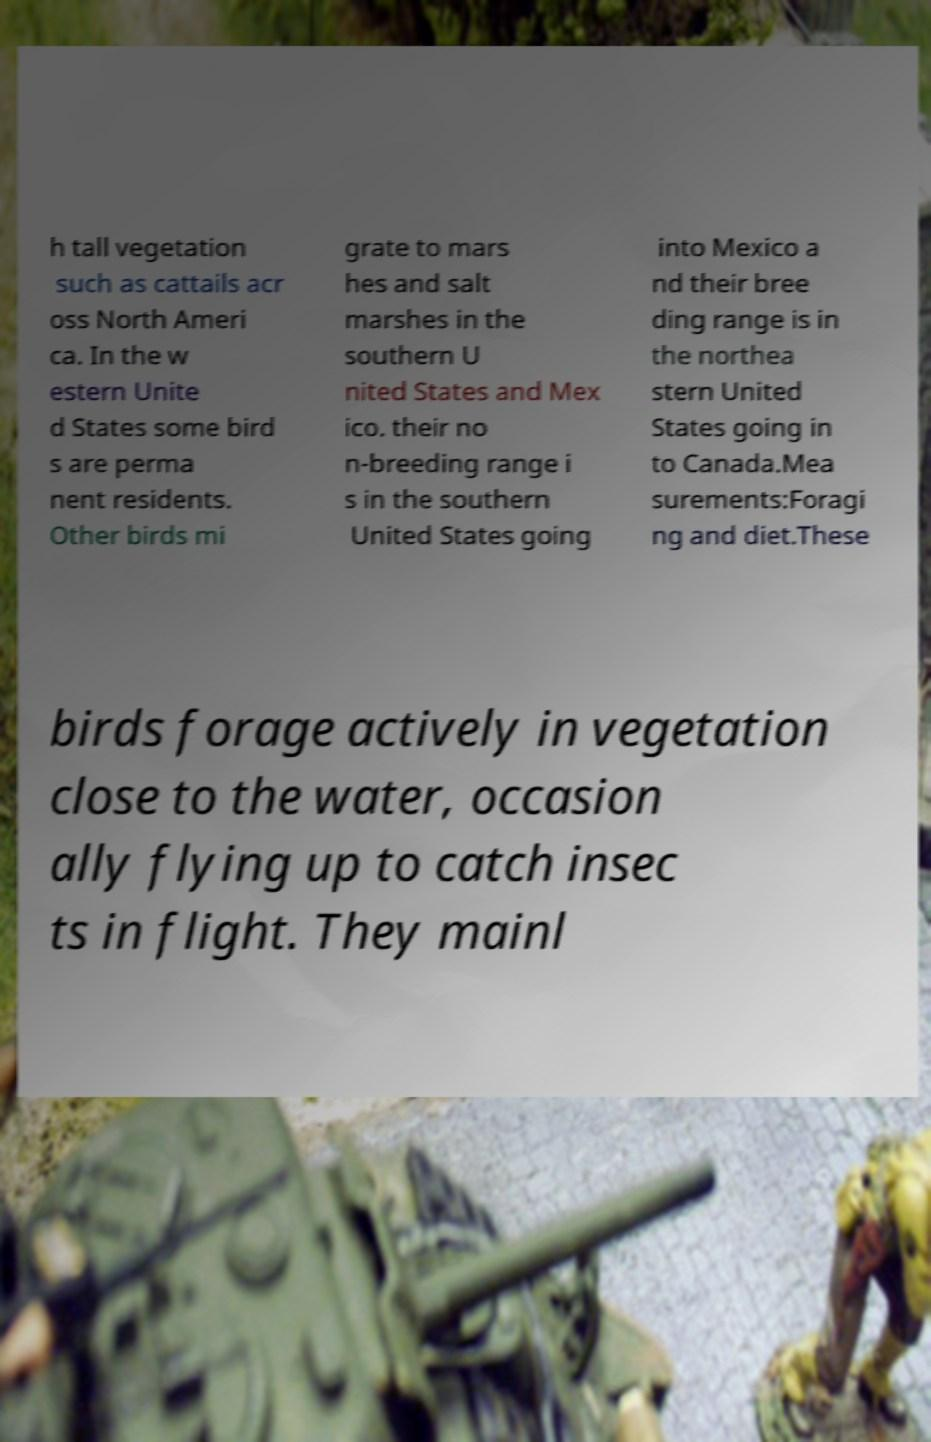Can you read and provide the text displayed in the image?This photo seems to have some interesting text. Can you extract and type it out for me? h tall vegetation such as cattails acr oss North Ameri ca. In the w estern Unite d States some bird s are perma nent residents. Other birds mi grate to mars hes and salt marshes in the southern U nited States and Mex ico. their no n-breeding range i s in the southern United States going into Mexico a nd their bree ding range is in the northea stern United States going in to Canada.Mea surements:Foragi ng and diet.These birds forage actively in vegetation close to the water, occasion ally flying up to catch insec ts in flight. They mainl 